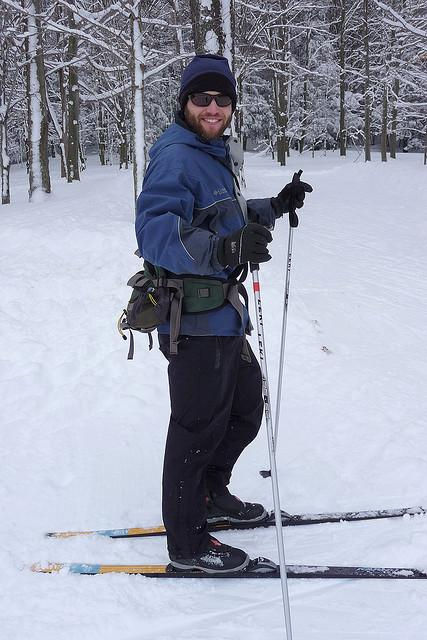What type of skiing is he likely doing? cross country 